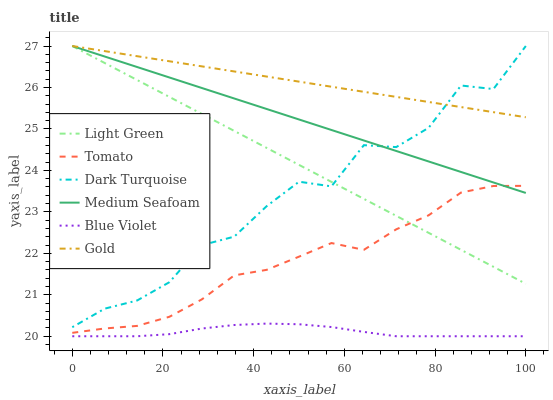Does Blue Violet have the minimum area under the curve?
Answer yes or no. Yes. Does Gold have the maximum area under the curve?
Answer yes or no. Yes. Does Dark Turquoise have the minimum area under the curve?
Answer yes or no. No. Does Dark Turquoise have the maximum area under the curve?
Answer yes or no. No. Is Medium Seafoam the smoothest?
Answer yes or no. Yes. Is Dark Turquoise the roughest?
Answer yes or no. Yes. Is Gold the smoothest?
Answer yes or no. No. Is Gold the roughest?
Answer yes or no. No. Does Blue Violet have the lowest value?
Answer yes or no. Yes. Does Dark Turquoise have the lowest value?
Answer yes or no. No. Does Medium Seafoam have the highest value?
Answer yes or no. Yes. Does Blue Violet have the highest value?
Answer yes or no. No. Is Blue Violet less than Medium Seafoam?
Answer yes or no. Yes. Is Tomato greater than Blue Violet?
Answer yes or no. Yes. Does Light Green intersect Medium Seafoam?
Answer yes or no. Yes. Is Light Green less than Medium Seafoam?
Answer yes or no. No. Is Light Green greater than Medium Seafoam?
Answer yes or no. No. Does Blue Violet intersect Medium Seafoam?
Answer yes or no. No. 